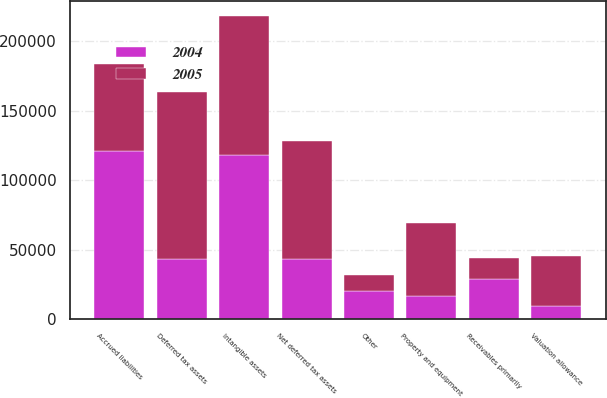<chart> <loc_0><loc_0><loc_500><loc_500><stacked_bar_chart><ecel><fcel>Receivables primarily<fcel>Accrued liabilities<fcel>Other<fcel>Deferred tax assets<fcel>Valuation allowance<fcel>Net deferred tax assets<fcel>Intangible assets<fcel>Property and equipment<nl><fcel>2004<fcel>28805<fcel>121404<fcel>20287<fcel>43748<fcel>9898<fcel>43748<fcel>118240<fcel>16930<nl><fcel>2005<fcel>15614<fcel>62478<fcel>11389<fcel>120070<fcel>35380<fcel>84690<fcel>100044<fcel>52116<nl></chart> 